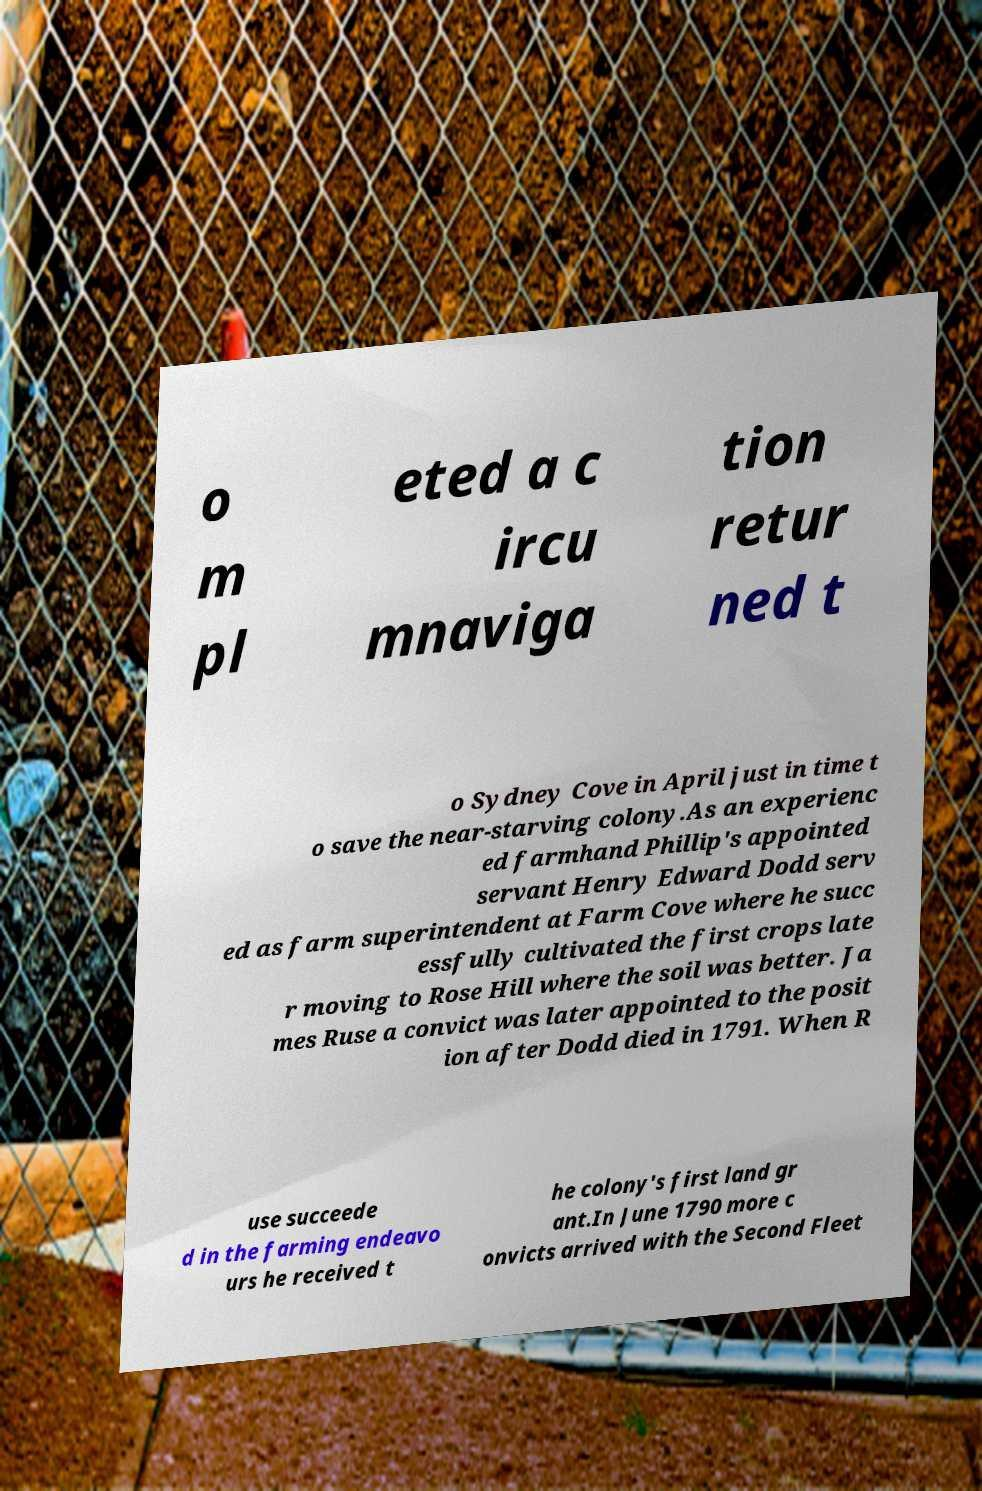There's text embedded in this image that I need extracted. Can you transcribe it verbatim? o m pl eted a c ircu mnaviga tion retur ned t o Sydney Cove in April just in time t o save the near-starving colony.As an experienc ed farmhand Phillip's appointed servant Henry Edward Dodd serv ed as farm superintendent at Farm Cove where he succ essfully cultivated the first crops late r moving to Rose Hill where the soil was better. Ja mes Ruse a convict was later appointed to the posit ion after Dodd died in 1791. When R use succeede d in the farming endeavo urs he received t he colony's first land gr ant.In June 1790 more c onvicts arrived with the Second Fleet 